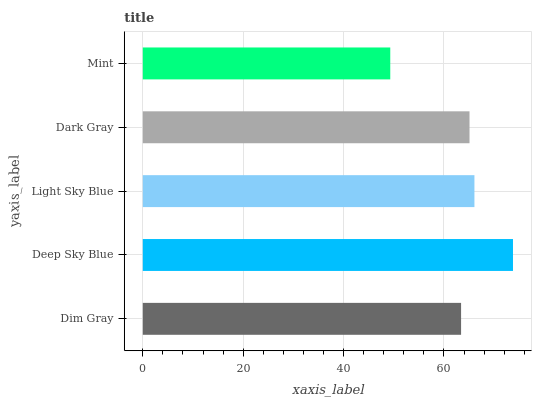Is Mint the minimum?
Answer yes or no. Yes. Is Deep Sky Blue the maximum?
Answer yes or no. Yes. Is Light Sky Blue the minimum?
Answer yes or no. No. Is Light Sky Blue the maximum?
Answer yes or no. No. Is Deep Sky Blue greater than Light Sky Blue?
Answer yes or no. Yes. Is Light Sky Blue less than Deep Sky Blue?
Answer yes or no. Yes. Is Light Sky Blue greater than Deep Sky Blue?
Answer yes or no. No. Is Deep Sky Blue less than Light Sky Blue?
Answer yes or no. No. Is Dark Gray the high median?
Answer yes or no. Yes. Is Dark Gray the low median?
Answer yes or no. Yes. Is Light Sky Blue the high median?
Answer yes or no. No. Is Mint the low median?
Answer yes or no. No. 